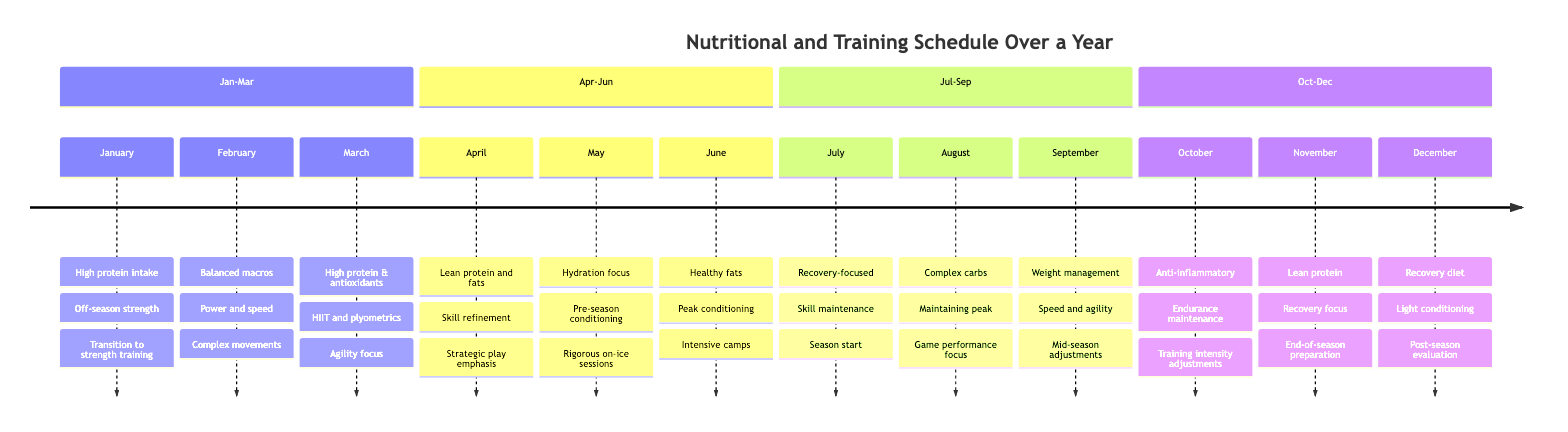What is the nutritional focus for June? According to the timeline for June, the nutritional focus is "Increased healthy fats and omega-3s."
Answer: Increased healthy fats and omega-3s What is the training focus during April? The timeline indicates that the training focus for April is "Skill refinement and on-ice tactical training."
Answer: Skill refinement and on-ice tactical training How many months emphasize hydration in their nutritional focus? By checking the nutritional focuses for each month, "Hydration and electrolytes" in May and "Lean protein and hydration focus" in November show a total of 2 months emphasizing hydration.
Answer: 2 What major change occurs in February? The major change highlighted for February in the timeline is "Incorporating more complex movements and hockey-specific skills."
Answer: Incorporating more complex movements and hockey-specific skills Which month has a training focus on "High-intensity interval training"? The month associated with "High-intensity interval training (HIIT) and plyometrics" is March, according to the timeline.
Answer: March In which months is the major focus on strategic play? Based on the timeline, April emphasizes "Emphasis on strategic play and situational practices" regarding the major changes and is the only month mentioning strategic play.
Answer: April What month marks the start of the regular season? The timeline indicates that the regular season starts in July, where the major change is "Regular season start, in-season training adjustments."
Answer: July What are the training focuses listed for the months of September and October? For September, the training focus is "Speed and agility drills, tactical refinement," and for October, it is "Endurance maintenance and game simulation."
Answer: Speed and agility drills, tactical refinement; Endurance maintenance and game simulation Which month is dedicated to light conditioning and recovery workouts? According to the timeline, December is the month dedicated to "Light conditioning and recovery workouts."
Answer: December How does the nutritional focus change from June to July? In June, the nutritional focus is "Increased healthy fats and omega-3s," while in July, it shifts to an "In-season meal plan focusing on recovery."
Answer: Increased healthy fats and omega-3s; In-season meal plan focusing on recovery 